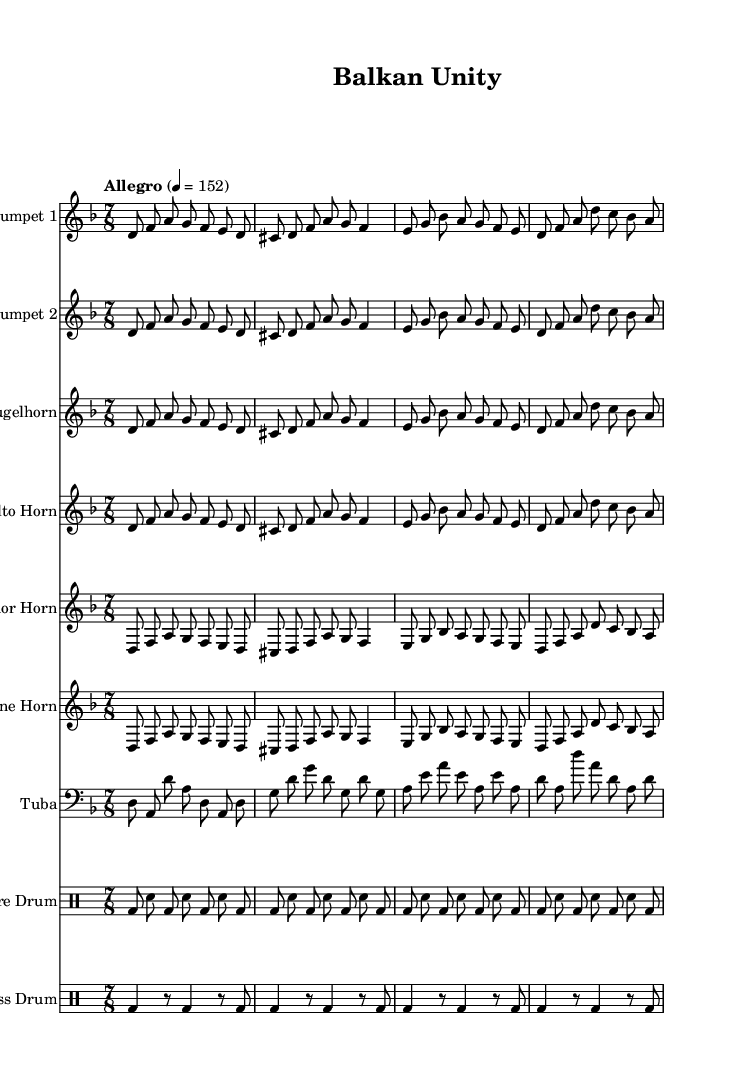What is the key signature of this music? The key signature is D minor, indicated at the beginning of the score by having one flat (B♭) in the key signature line.
Answer: D minor What is the time signature of this music? The time signature is 7/8, which is indicated by the "7/8" notation found at the beginning of the score right after the key signature.
Answer: 7/8 What is the tempo marking of this piece? The tempo marking is "Allegro" and it specifies a speed of quarter note equals 152 beats per minute, which can be found in the tempo instruction at the beginning of the score.
Answer: Allegro, 152 How many instruments are in this score? The score contains seven distinct instrumental parts; two trumpets, one flugelhorn, one alto horn, one tenor horn, one baritone horn, and one tuba, along with snare and bass drums. This can be counted by reviewing the staff names labeled at the beginning of each section.
Answer: Seven What is the rhythmic pattern used in the snare drum line? The snare drum line consists of alternating beats of bass drums (bd) and snare drums (sn), following a repeated pattern that can be observed throughout the score. The specific notation can be examined by looking at the rhythmic figure displayed in the drum staff, where the alternating beats show the consistent 7/8 pattern.
Answer: Alternating snare and bass What type of cultural themes does "Balkan Unity" address? The title "Balkan Unity" suggests themes of recovery and cultural unity in the context of Balkan brass band music, which is often reflective of community and reconciliation in post-war settings. This context can be inferred from the title and the music's historical association with cultural gathering and communal celebration.
Answer: Post-war recovery, cultural unity 